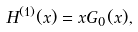Convert formula to latex. <formula><loc_0><loc_0><loc_500><loc_500>H ^ { ( 1 ) } ( x ) = x G _ { 0 } ( x ) ,</formula> 